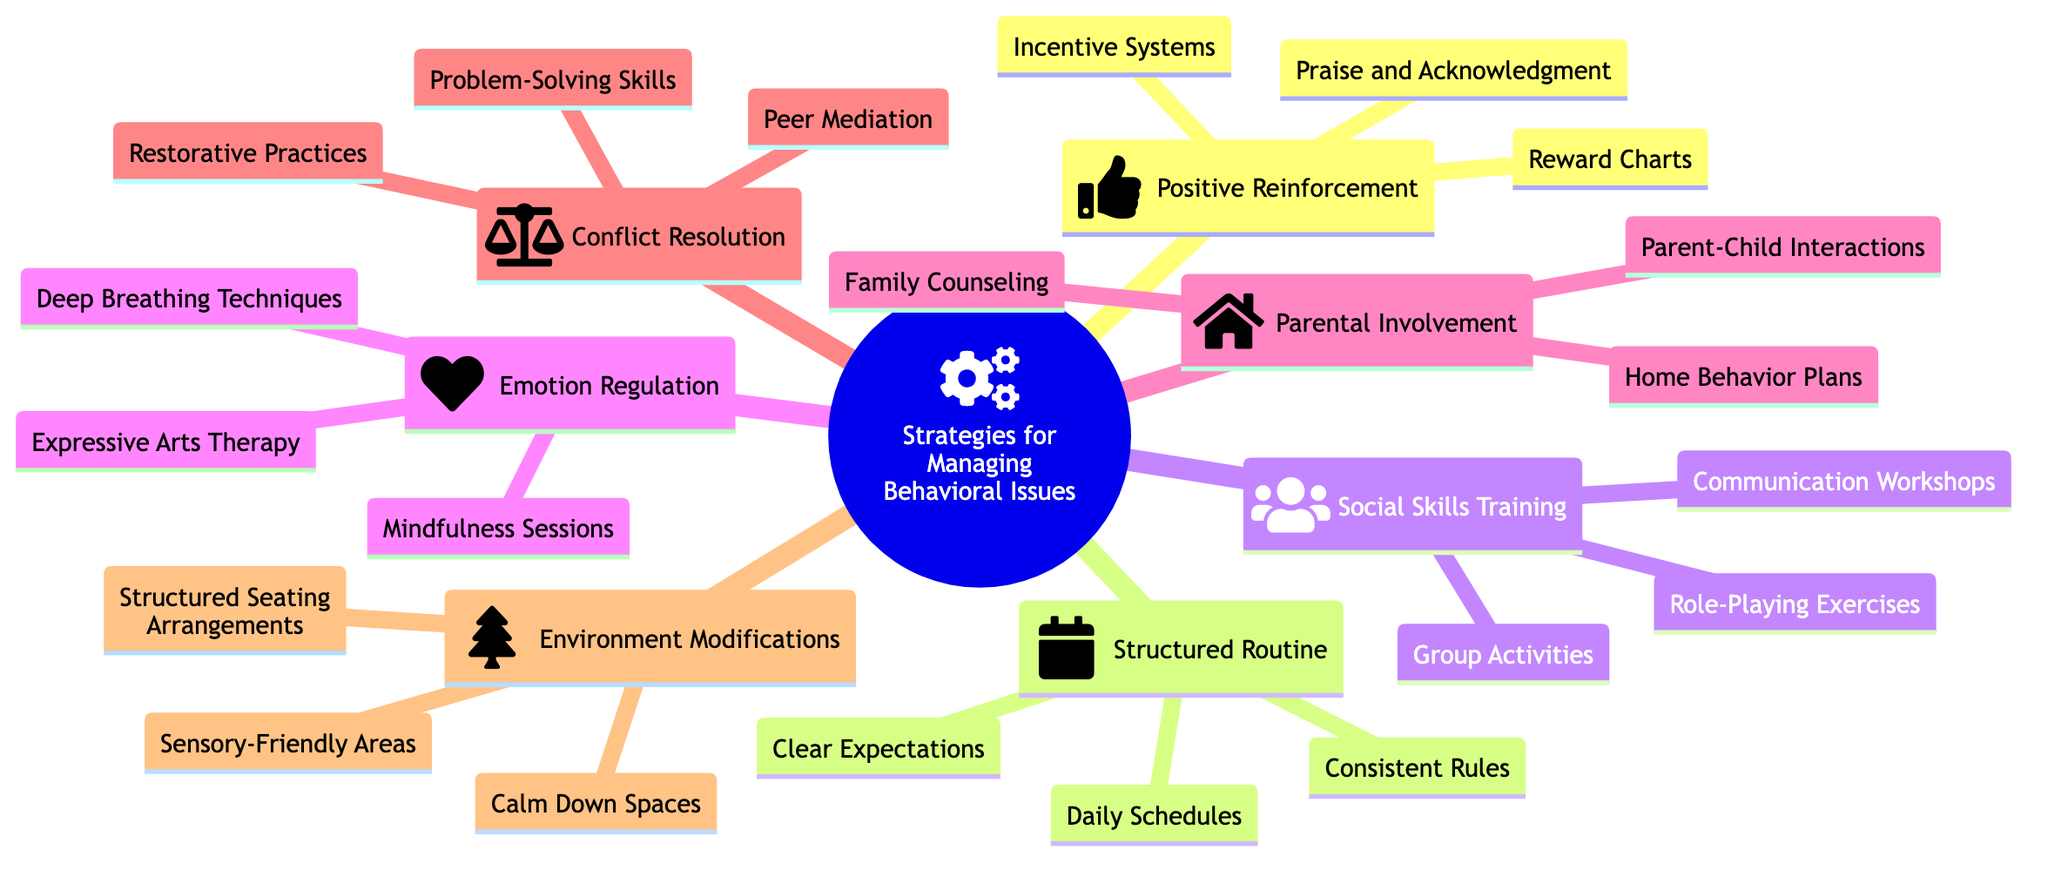What is the center topic of the mind map? The center topic is the main focus of the mind map, typically represented at the center. It can be found labeled as "Strategies for Managing Behavioral Issues."
Answer: Strategies for Managing Behavioral Issues How many categories are listed in the mind map? The categories can be counted by reviewing each main branch extending from the center topic. There are a total of seven categories in the mind map.
Answer: 7 What is one method under Positive Reinforcement? To find a method under Positive Reinforcement, I can look under that category and see that one of the sub-elements listed is "Praise and Acknowledgment."
Answer: Praise and Acknowledgment Which category includes "Mindfulness Sessions"? To find this, I look for "Mindfulness Sessions" in the sub-elements of each category. It is listed under the category "Emotion Regulation."
Answer: Emotion Regulation What are the sub-elements of Conflict Resolution? The sub-elements of Conflict Resolution can be identified by examining the elements under that specific category in the diagram. They include "Problem-Solving Skills," "Peer Mediation," and "Restorative Practices."
Answer: Problem-Solving Skills, Peer Mediation, Restorative Practices Which category has a focus on interactions between parents and children? The category focusing on interactions between parents and children can be found by looking at the relevant titles in the diagram. It is under "Parental Involvement."
Answer: Parental Involvement How many sub-elements does the Environment Modifications category contain? By reviewing the Environment Modifications category, I can count its sub-elements: "Calm Down Spaces," "Sensory-Friendly Areas," and "Structured Seating Arrangements." There are three sub-elements in total.
Answer: 3 What is the relationship between Structured Routine and Clear Expectations? To understand the relationship, I consider that "Clear Expectations" is a sub-element within the "Structured Routine" category, indicating it is a strategy that creates a structured environment.
Answer: Clear Expectations is a sub-element of Structured Routine What strategy would you use to help with Emotion Regulation? To help with Emotion Regulation, I can refer to the methods listed in the Emotion Regulation category, such as "Deep Breathing Techniques."
Answer: Deep Breathing Techniques 